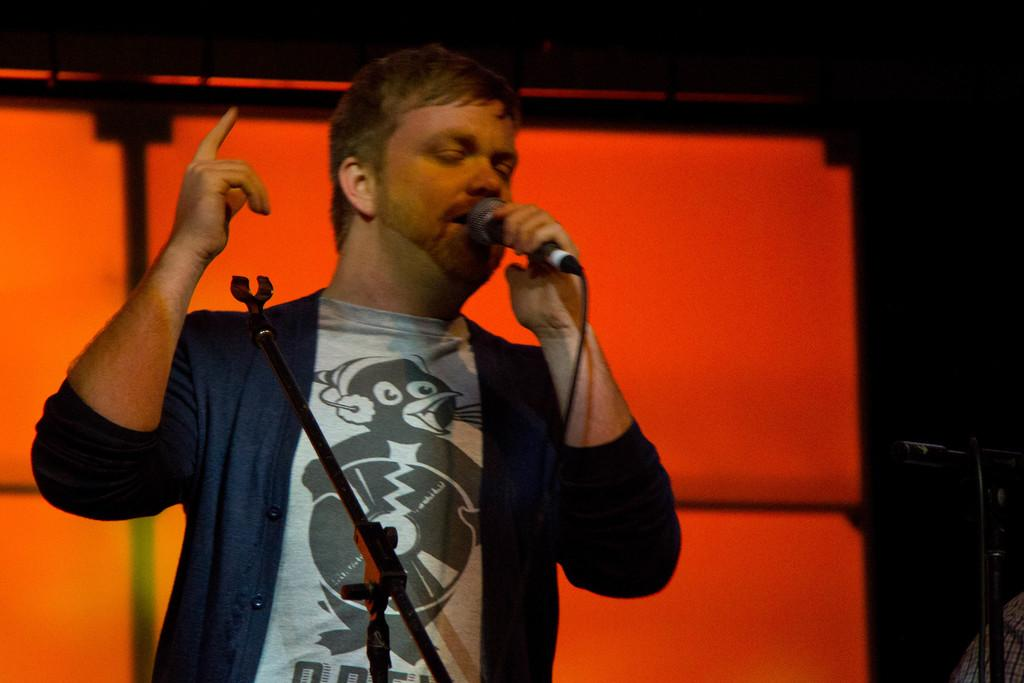What is the man in the image doing? The man is standing in the image and holding a mic. What objects are related to the mic in the image? There are microphone stands in the image. What can be seen in the background of the image? There appears to be a screen in the background of the image. What type of plough is being used in the image? There is no plough present in the image. How does the man fall off the stage in the image? The man does not fall off the stage in the image; he is standing and holding a mic. 